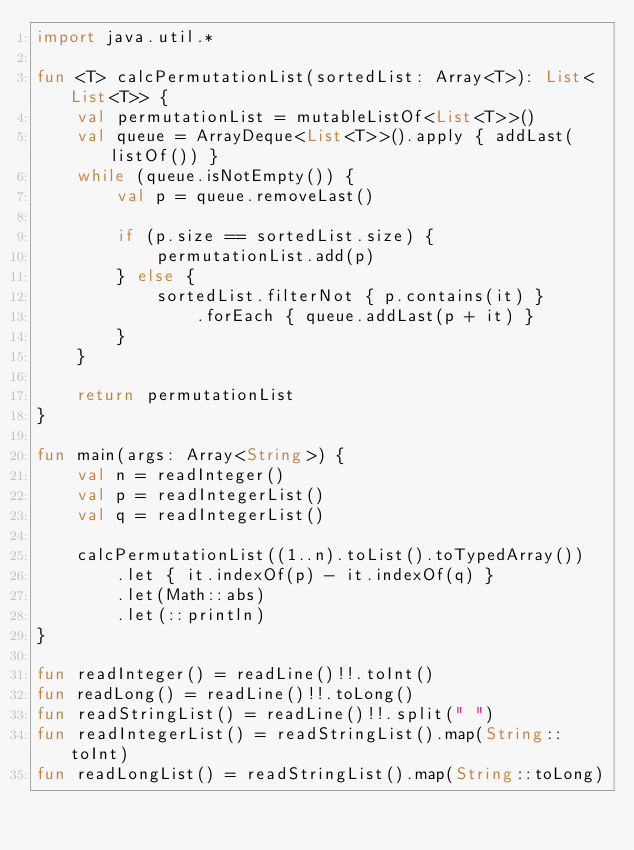<code> <loc_0><loc_0><loc_500><loc_500><_Kotlin_>import java.util.*

fun <T> calcPermutationList(sortedList: Array<T>): List<List<T>> {
    val permutationList = mutableListOf<List<T>>()
    val queue = ArrayDeque<List<T>>().apply { addLast(listOf()) }
    while (queue.isNotEmpty()) {
        val p = queue.removeLast()

        if (p.size == sortedList.size) {
            permutationList.add(p)
        } else {
            sortedList.filterNot { p.contains(it) }
                .forEach { queue.addLast(p + it) }
        }
    }

    return permutationList
}

fun main(args: Array<String>) {
    val n = readInteger()
    val p = readIntegerList()
    val q = readIntegerList()

    calcPermutationList((1..n).toList().toTypedArray())
        .let { it.indexOf(p) - it.indexOf(q) }
        .let(Math::abs)
        .let(::println)
}

fun readInteger() = readLine()!!.toInt()
fun readLong() = readLine()!!.toLong()
fun readStringList() = readLine()!!.split(" ")
fun readIntegerList() = readStringList().map(String::toInt)
fun readLongList() = readStringList().map(String::toLong)
</code> 